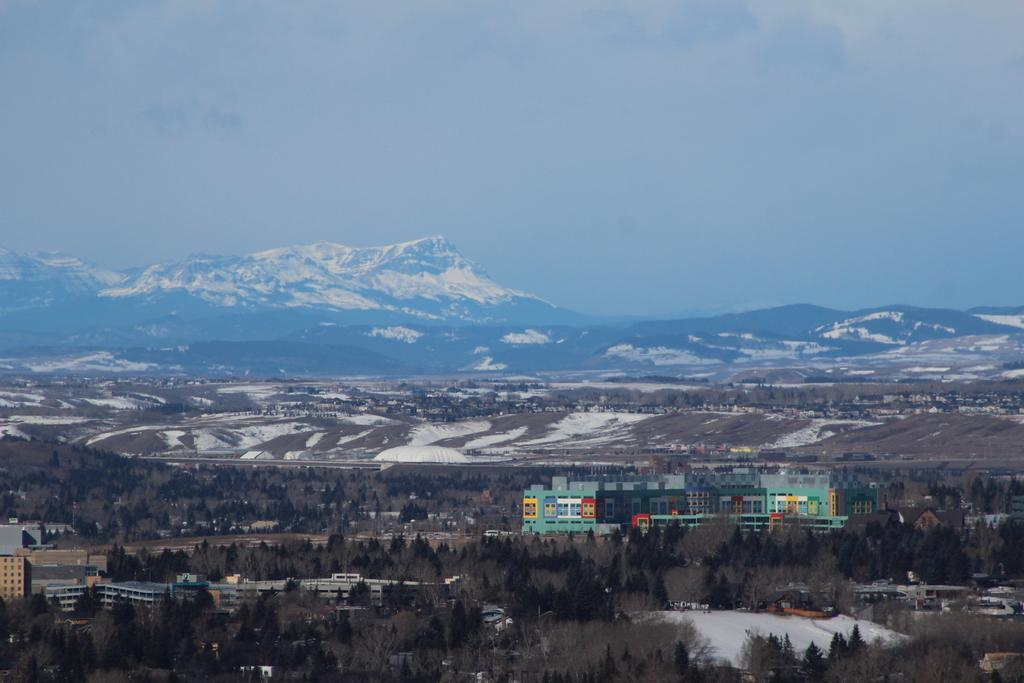What type of vegetation is present in the image? There are many trees in the image. What type of structures can be seen in the image? There are buildings in the image. What is the weather like in the image? There is snow in the image, indicating a cold or wintery environment. What can be seen in the distance in the image? There are hills visible in the background of the image. What is visible above the trees and buildings in the image? The sky is visible in the background of the image. What is the current status of the town in the image? There is no indication of a town in the image, only trees, buildings, snow, hills, and the sky are visible. What is the source of shame in the image? There is no indication of shame or any negative emotion in the image; it depicts a snowy landscape with trees, buildings, hills, and the sky. 